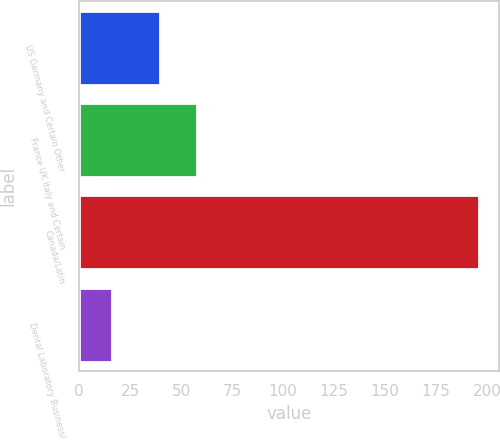Convert chart to OTSL. <chart><loc_0><loc_0><loc_500><loc_500><bar_chart><fcel>US Germany and Certain Other<fcel>France UK Italy and Certain<fcel>Canada/Latin<fcel>Dental Laboratory Business/<nl><fcel>39.7<fcel>57.69<fcel>195.8<fcel>15.9<nl></chart> 